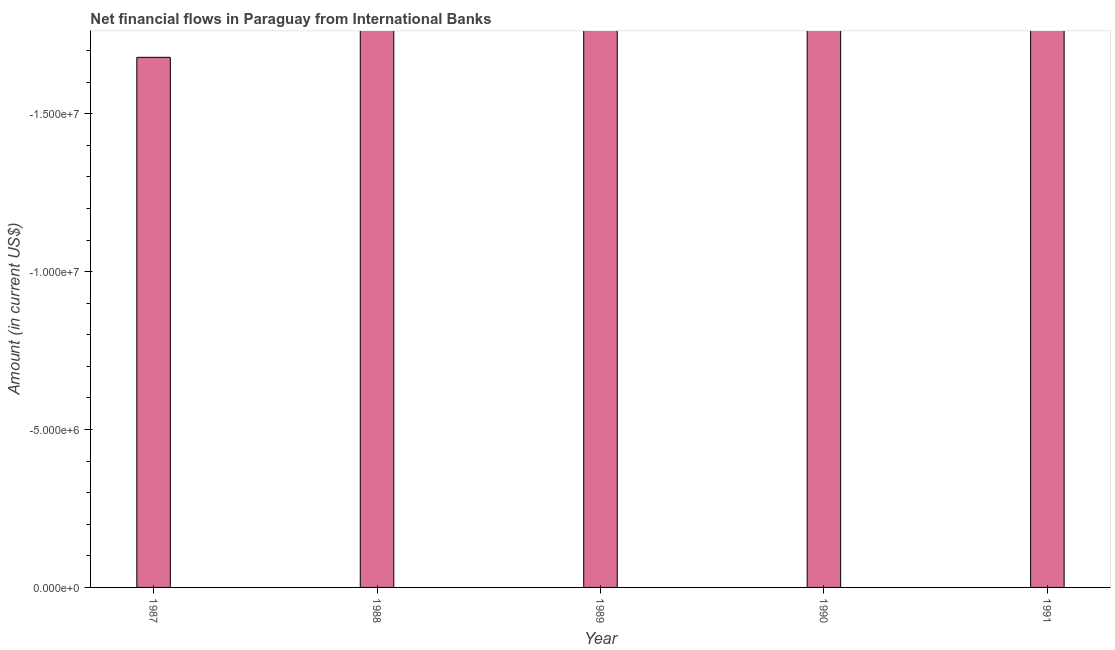Does the graph contain any zero values?
Your response must be concise. Yes. What is the title of the graph?
Offer a very short reply. Net financial flows in Paraguay from International Banks. What is the label or title of the X-axis?
Provide a short and direct response. Year. What is the label or title of the Y-axis?
Keep it short and to the point. Amount (in current US$). Across all years, what is the minimum net financial flows from ibrd?
Your answer should be very brief. 0. What is the sum of the net financial flows from ibrd?
Ensure brevity in your answer.  0. What is the average net financial flows from ibrd per year?
Make the answer very short. 0. What is the median net financial flows from ibrd?
Keep it short and to the point. 0. In how many years, is the net financial flows from ibrd greater than -12000000 US$?
Your response must be concise. 0. How many bars are there?
Ensure brevity in your answer.  0. What is the Amount (in current US$) in 1987?
Your response must be concise. 0. What is the Amount (in current US$) in 1990?
Offer a very short reply. 0. What is the Amount (in current US$) in 1991?
Give a very brief answer. 0. 